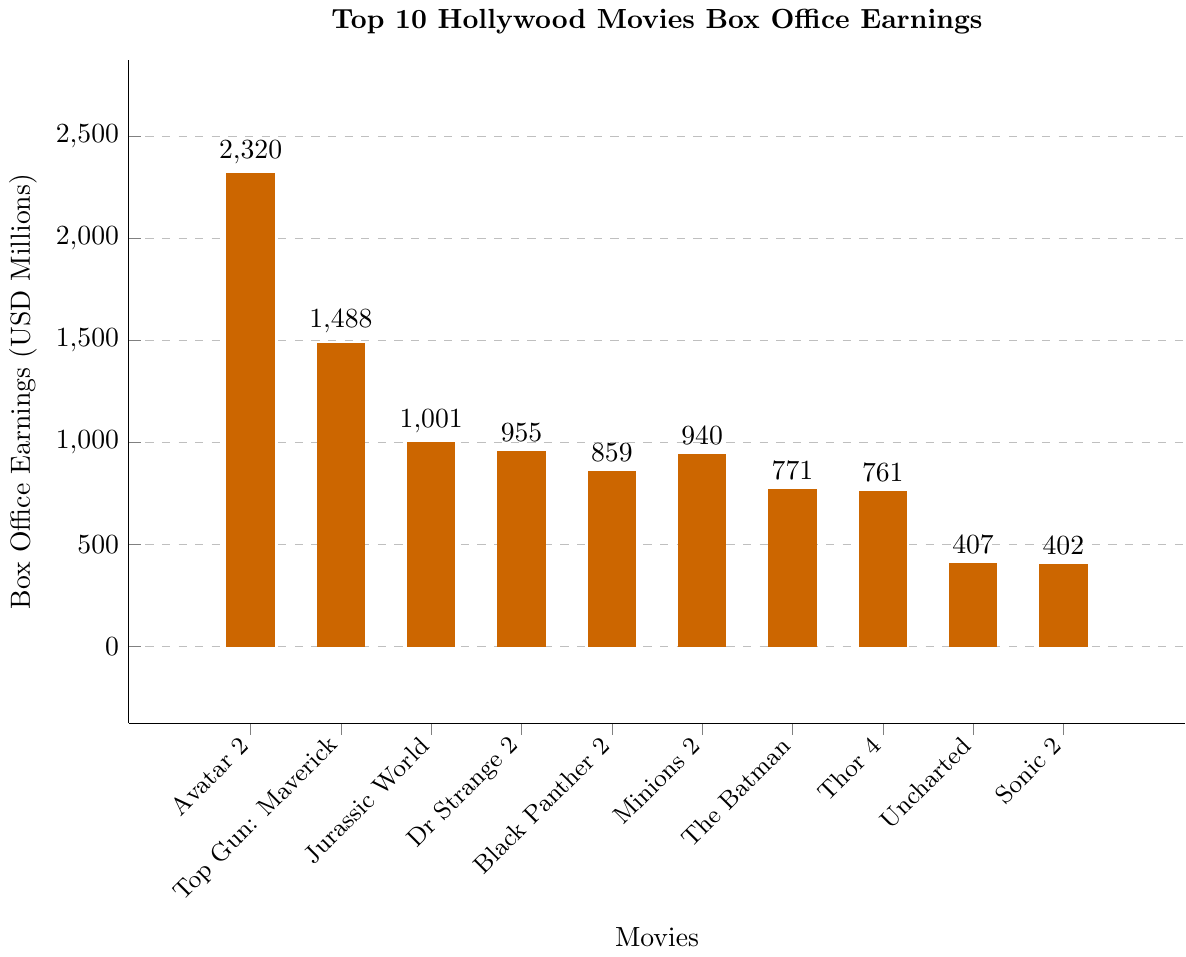Which movie has the highest box office earnings? Look at the bar with the greatest height or value. The bar at position 1 (Avatar: The Way of Water) has the highest value of 2320 million USD.
Answer: Avatar: The Way of Water What is the total box office earnings for Jurassic World: Dominion and Doctor Strange in the Multiverse of Madness? Sum the earnings for the two movies. Jurassic World: Dominion has 1001 million USD, and Doctor Strange in the Multiverse of Madness has 955 million USD. The total is 1001 + 955 = 1956 million USD.
Answer: 1956 million USD Which movie earned more, Sonic the Hedgehog 2 or Uncharted? Compare the heights of the two bars. Sonic the Hedgehog 2 earned 402 million USD, while Uncharted earned 407 million USD. Uncharted earns more.
Answer: Uncharted What is the difference in box office earnings between Top Gun: Maverick and Black Panther: Wakanda Forever? Subtract the earnings of Black Panther: Wakanda Forever from Top Gun: Maverick. Top Gun: Maverick earned 1488 million USD, and Black Panther: Wakanda Forever earned 859 million USD. The difference is 1488 - 859 = 629 million USD.
Answer: 629 million USD What is the average earnings of the top 5 movies? Sum the earnings of the top 5 movies and divide by 5. The top 5 movies are: Avatar: The Way of Water (2320), Top Gun: Maverick (1488), Jurassic World: Dominion (1001), Doctor Strange in the Multiverse of Madness (955), and Black Panther: Wakanda Forever (859). The sum is 2320 + 1488 + 1001 + 955 + 859 = 6623 million USD. The average is 6623 / 5 = 1324.6 million USD.
Answer: 1324.6 million USD Which two movies have the closest earnings? Compare the differences between each pair of adjacent bars. The smallest difference is between Sonic the Hedgehog 2 (402) and Uncharted (407) with a difference of 407 - 402 = 5 million USD.
Answer: Sonic the Hedgehog 2 and Uncharted By how much do the earnings of Minions: The Rise of Gru exceed the earnings of Thor: Love and Thunder? Subtract the earnings of Thor: Love and Thunder from Minions: The Rise of Gru. Minions: The Rise of Gru earned 940 million USD, and Thor: Love and Thunder earned 761 million USD. The difference is 940 - 761 = 179 million USD.
Answer: 179 million USD Is the average earnings of the bottom 5 movies greater than 500 million USD? First, determine the bottom 5 movies and find their average. The bottom 5 movies are: Sonic the Hedgehog 2 (402), Uncharted (407), The Batman (771), Thor: Love and Thunder (761), and Minions: The Rise of Gru (940). The sum is 402 + 407 + 771 + 761 + 940 = 3281 million USD. The average is 3281 / 5 = 656.2 million USD, which is greater than 500 million USD.
Answer: Yes, it is greater Which movie out of the top 5 earned the least? Look at the bars representing the top 5 movies and find the one with the smallest height. Black Panther: Wakanda Forever has the lowest earnings among the top 5 movies with 859 million USD.
Answer: Black Panther: Wakanda Forever 